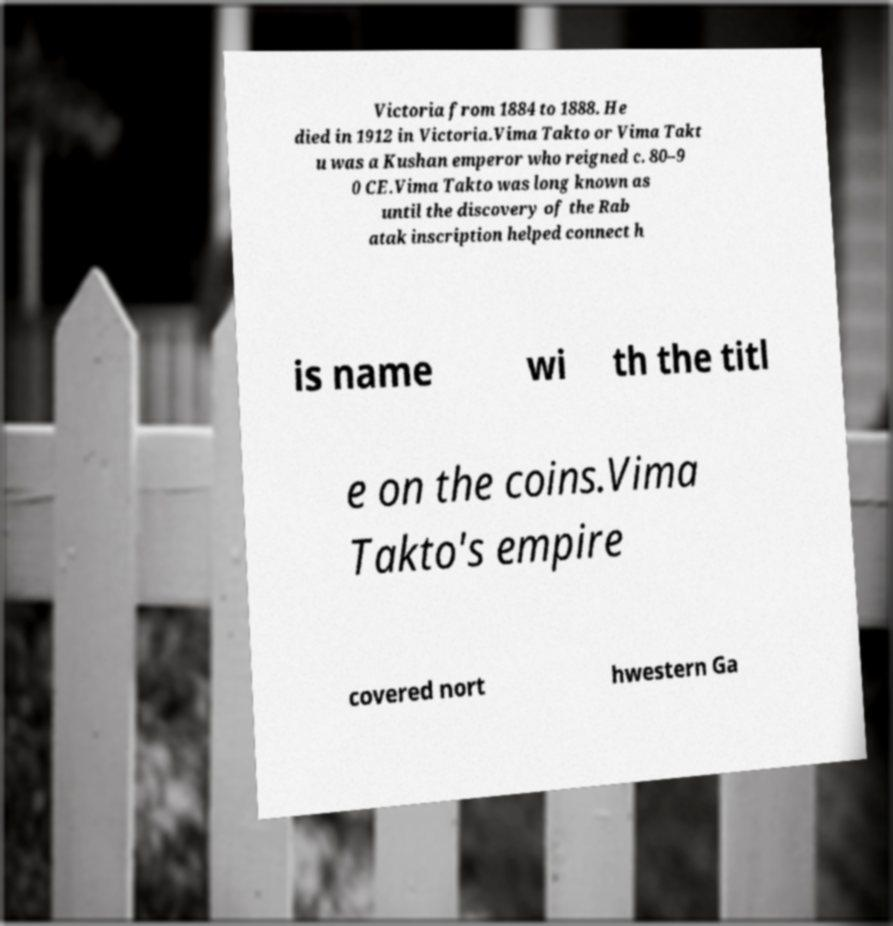Can you accurately transcribe the text from the provided image for me? Victoria from 1884 to 1888. He died in 1912 in Victoria.Vima Takto or Vima Takt u was a Kushan emperor who reigned c. 80–9 0 CE.Vima Takto was long known as until the discovery of the Rab atak inscription helped connect h is name wi th the titl e on the coins.Vima Takto's empire covered nort hwestern Ga 